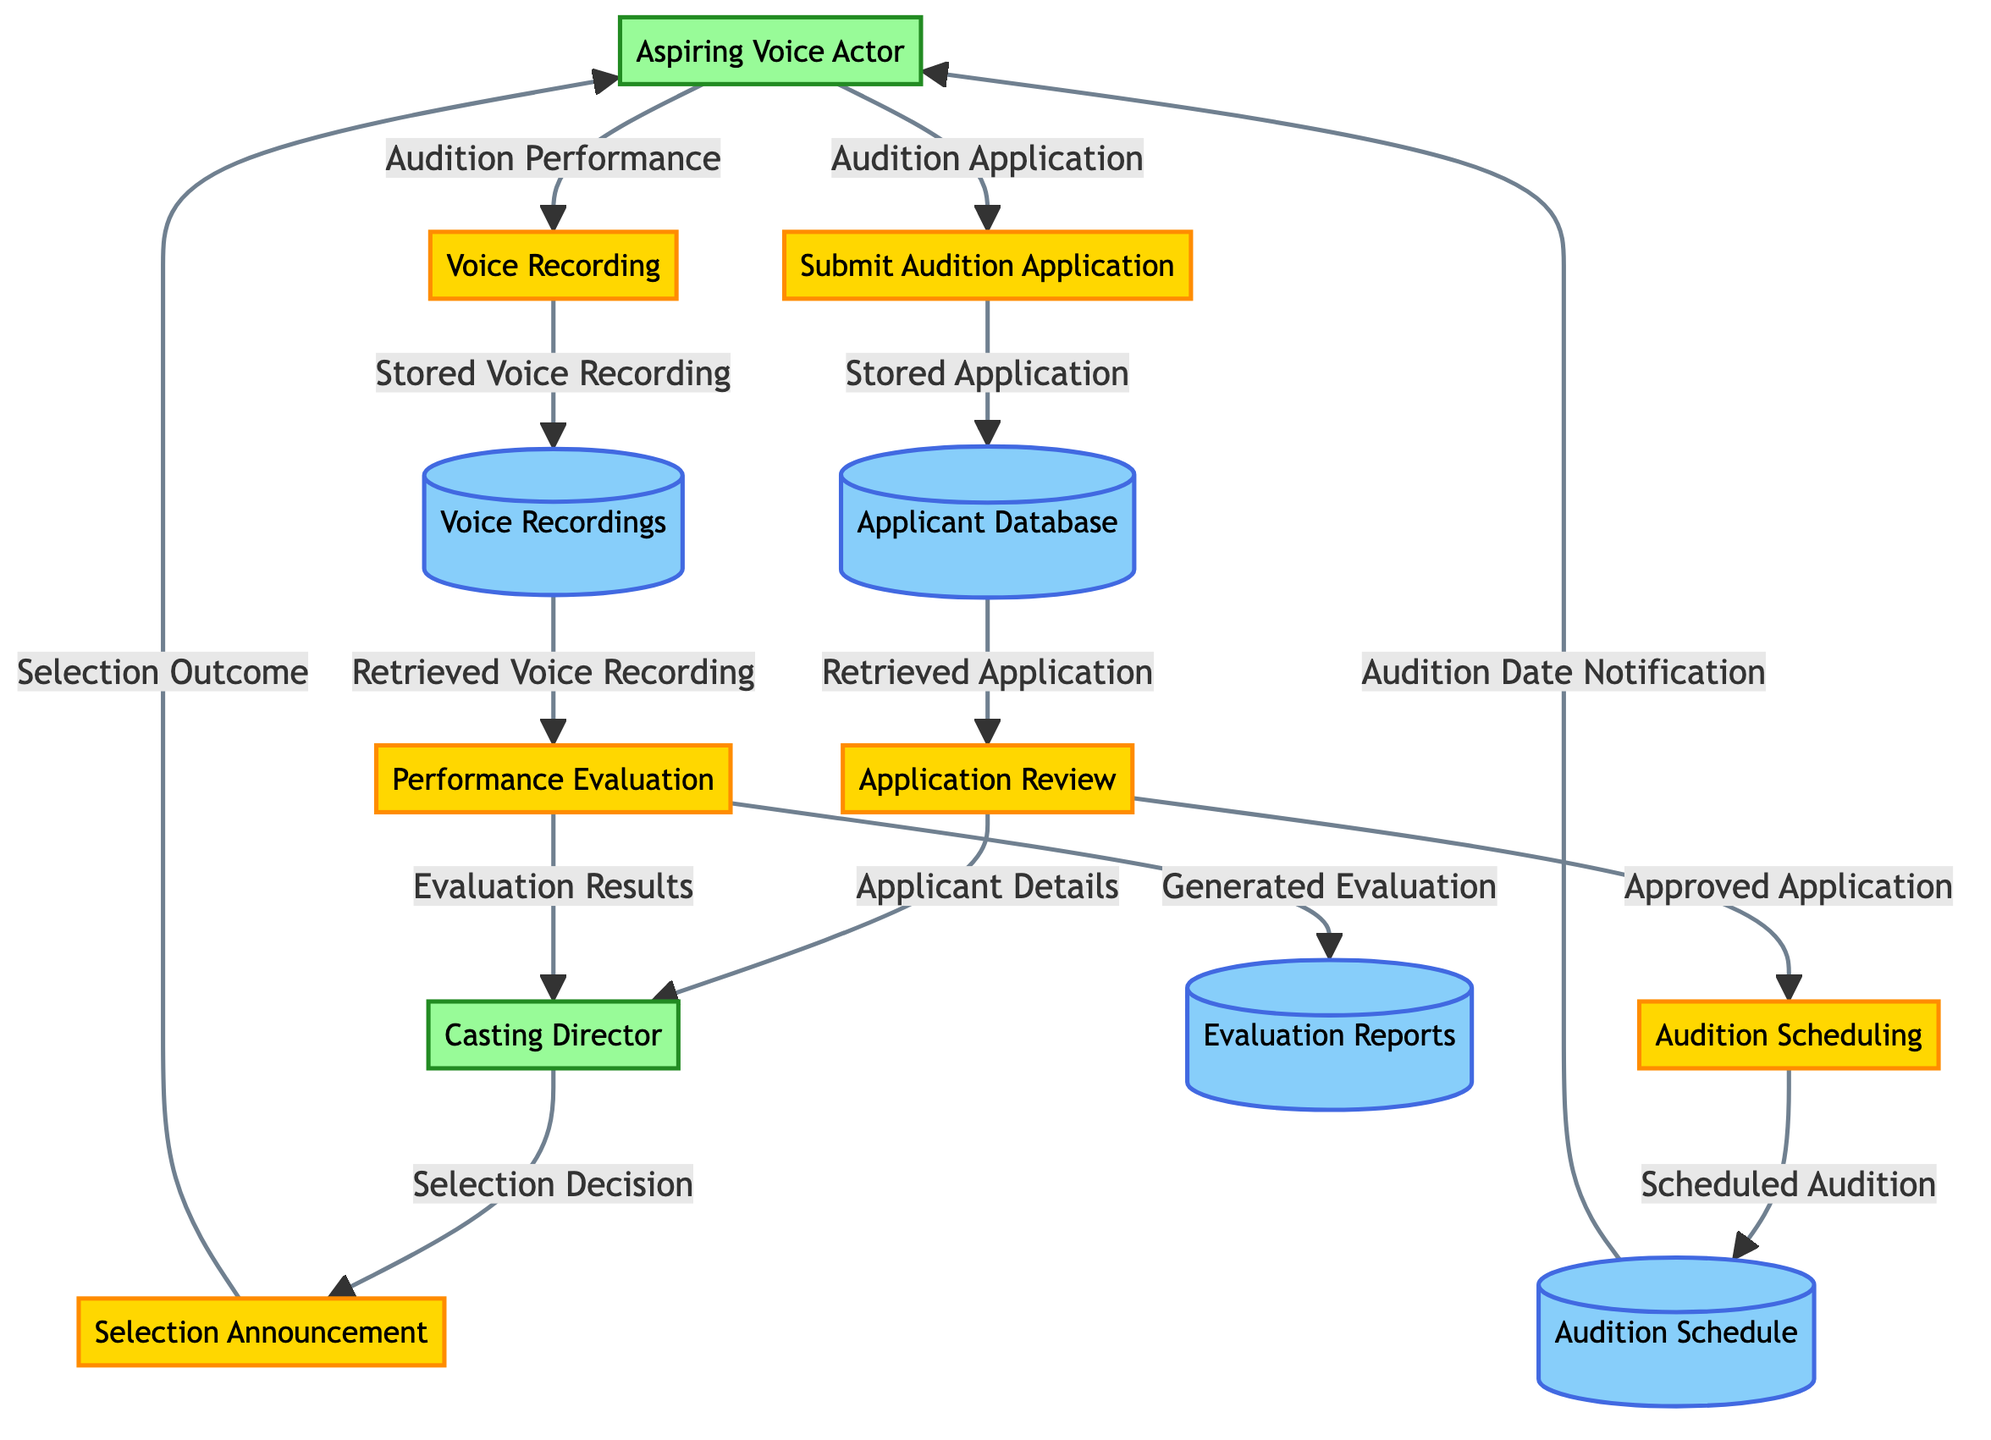What is the first process in the audition flow? The first process in the diagram is labeled "Submit Audition Application," which starts the flow of the audition process for aspiring voice actors.
Answer: Submit Audition Application How many data stores are present in the diagram? The diagram contains four data stores, which are Applicant Database, Audition Schedule, Voice Recordings, and Evaluation Reports.
Answer: 4 Who receives the "Selection Outcome"? The "Selection Outcome" is sent to the "Aspiring Voice Actor," indicating the conclusion of the audition process.
Answer: Aspiring Voice Actor What information flows from "Performance Evaluation" to the "Casting Director"? The evaluation results are sent from "Performance Evaluation" to "Casting Director," providing insights on the applicant's performance.
Answer: Evaluation Results What is the final process in the audition flow? The final process in the diagram is labeled "Selection Announcement," which indicates the last step of the auditioning process before informing the applicants.
Answer: Selection Announcement Which entity interacts with the "Voice Recording" process? The entity that interacts specifically with the "Voice Recording" process is the "Aspiring Voice Actor," who provides their audition performance for evaluation.
Answer: Aspiring Voice Actor What data flow comes from "Audition Scheduling" to "Audition Schedule"? The data flow named "Scheduled Audition" moves from "Audition Scheduling" to "Audition Schedule," documenting the scheduled time for the audition.
Answer: Scheduled Audition How does the "Application Review" process lead to scheduling auditions? The "Application Review" process sends an "Approved Application" to "Audition Scheduling," which facilitates the next step of determining the audition dates.
Answer: Approved Application 